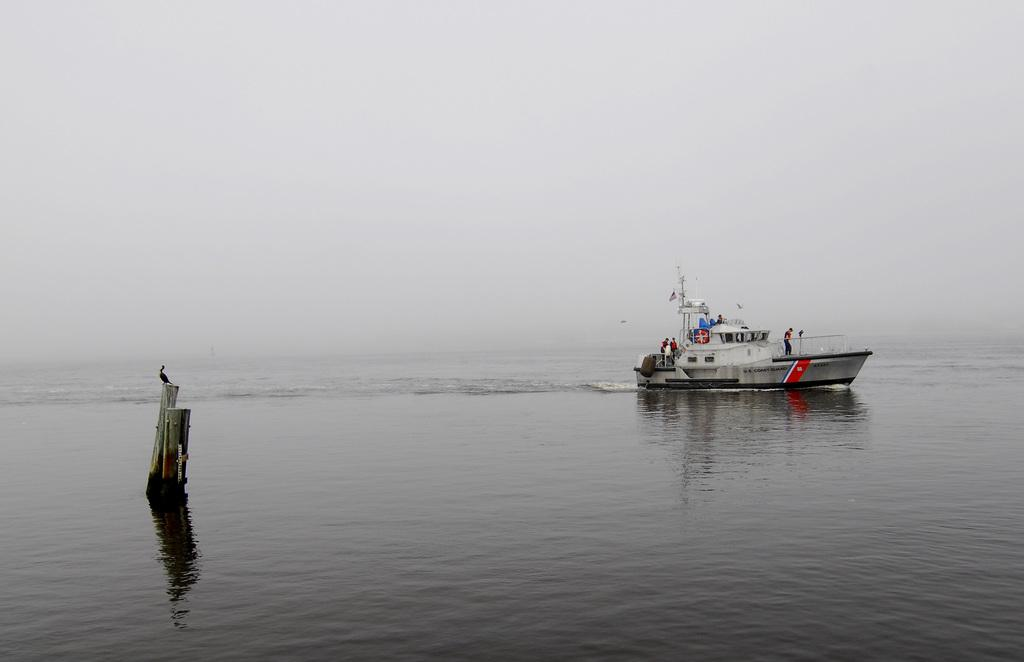What activity are the people in the image engaged in? The people in the image are sailing a boat. Where is the boat located? The boat is on the water. What else can be seen in the image besides the boat and people? There are poles in the image, and a bird is perched on one of the poles. What can be seen in the background of the image? The sky is visible in the background of the image. Where is the shelf located in the image? There is no shelf present in the image. Can you describe the boy's outfit in the image? There is no boy present in the image. 